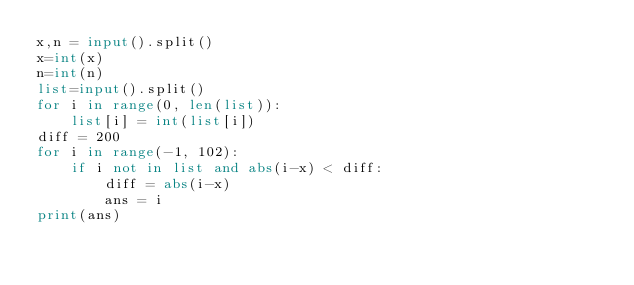Convert code to text. <code><loc_0><loc_0><loc_500><loc_500><_Python_>x,n = input().split()
x=int(x)
n=int(n)
list=input().split()
for i in range(0, len(list)):
    list[i] = int(list[i])
diff = 200
for i in range(-1, 102):
    if i not in list and abs(i-x) < diff:
        diff = abs(i-x)
        ans = i
print(ans)</code> 